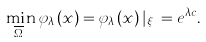<formula> <loc_0><loc_0><loc_500><loc_500>\min _ { \overline { \Omega } _ { c } } \varphi _ { \lambda } \left ( x \right ) = \varphi _ { \lambda } \left ( x \right ) | _ { \xi _ { c } } = e ^ { \lambda c } .</formula> 